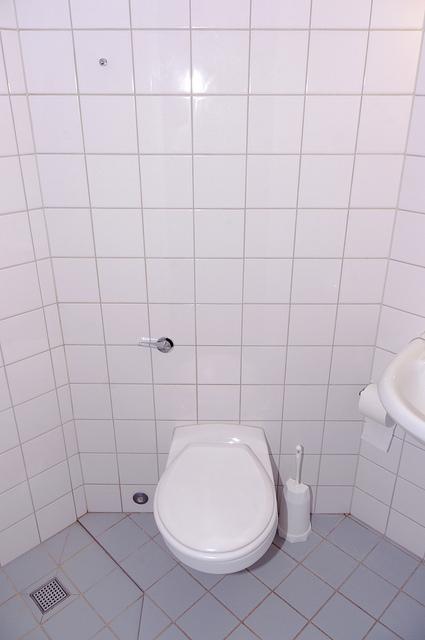How many tiles are in the shot?
Concise answer only. Many. Is the bathroom clean?
Keep it brief. Yes. Could you find the mirror in this photo?
Write a very short answer. No. What is on the floor near the toilet?
Keep it brief. Toilet brush. What does the handle on the wall do?
Write a very short answer. Flush toilet. How many rolls of toilet paper are there?
Be succinct. 1. Is a meal being prepared?
Keep it brief. No. Does this bathroom look clean?
Give a very brief answer. Yes. Is the toilet out of order?
Answer briefly. No. 